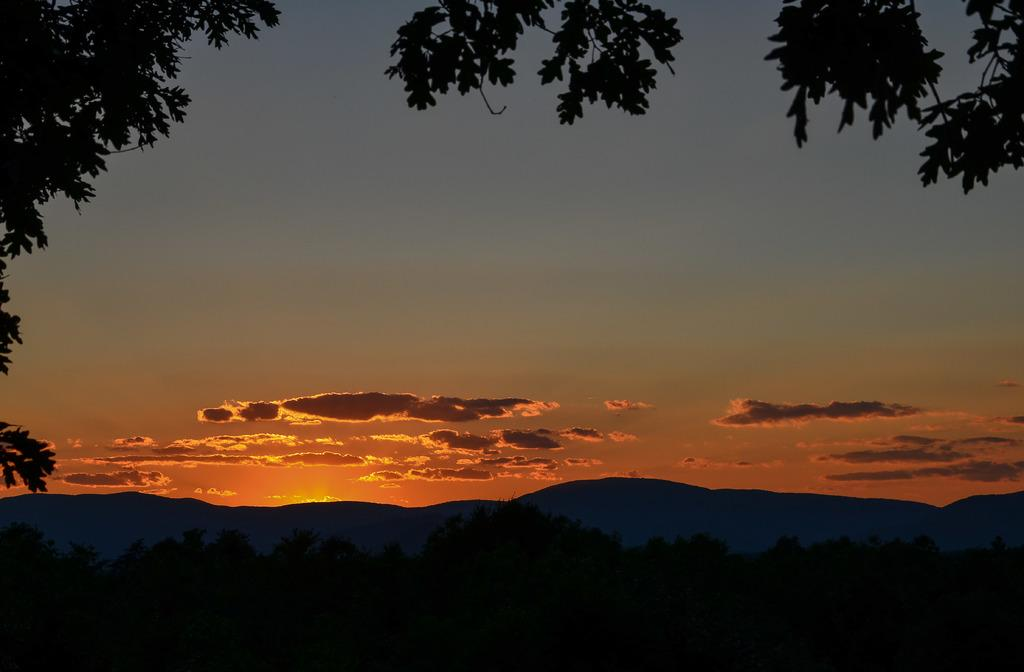What type of vegetation can be seen in the image? There are trees in the image. What geographical features are present in the image? There are hills in the image. What can be seen in the sky in the image? There are clouds in the image. How many legs can be seen on the trees in the image? Trees do not have legs, so this question cannot be answered. 